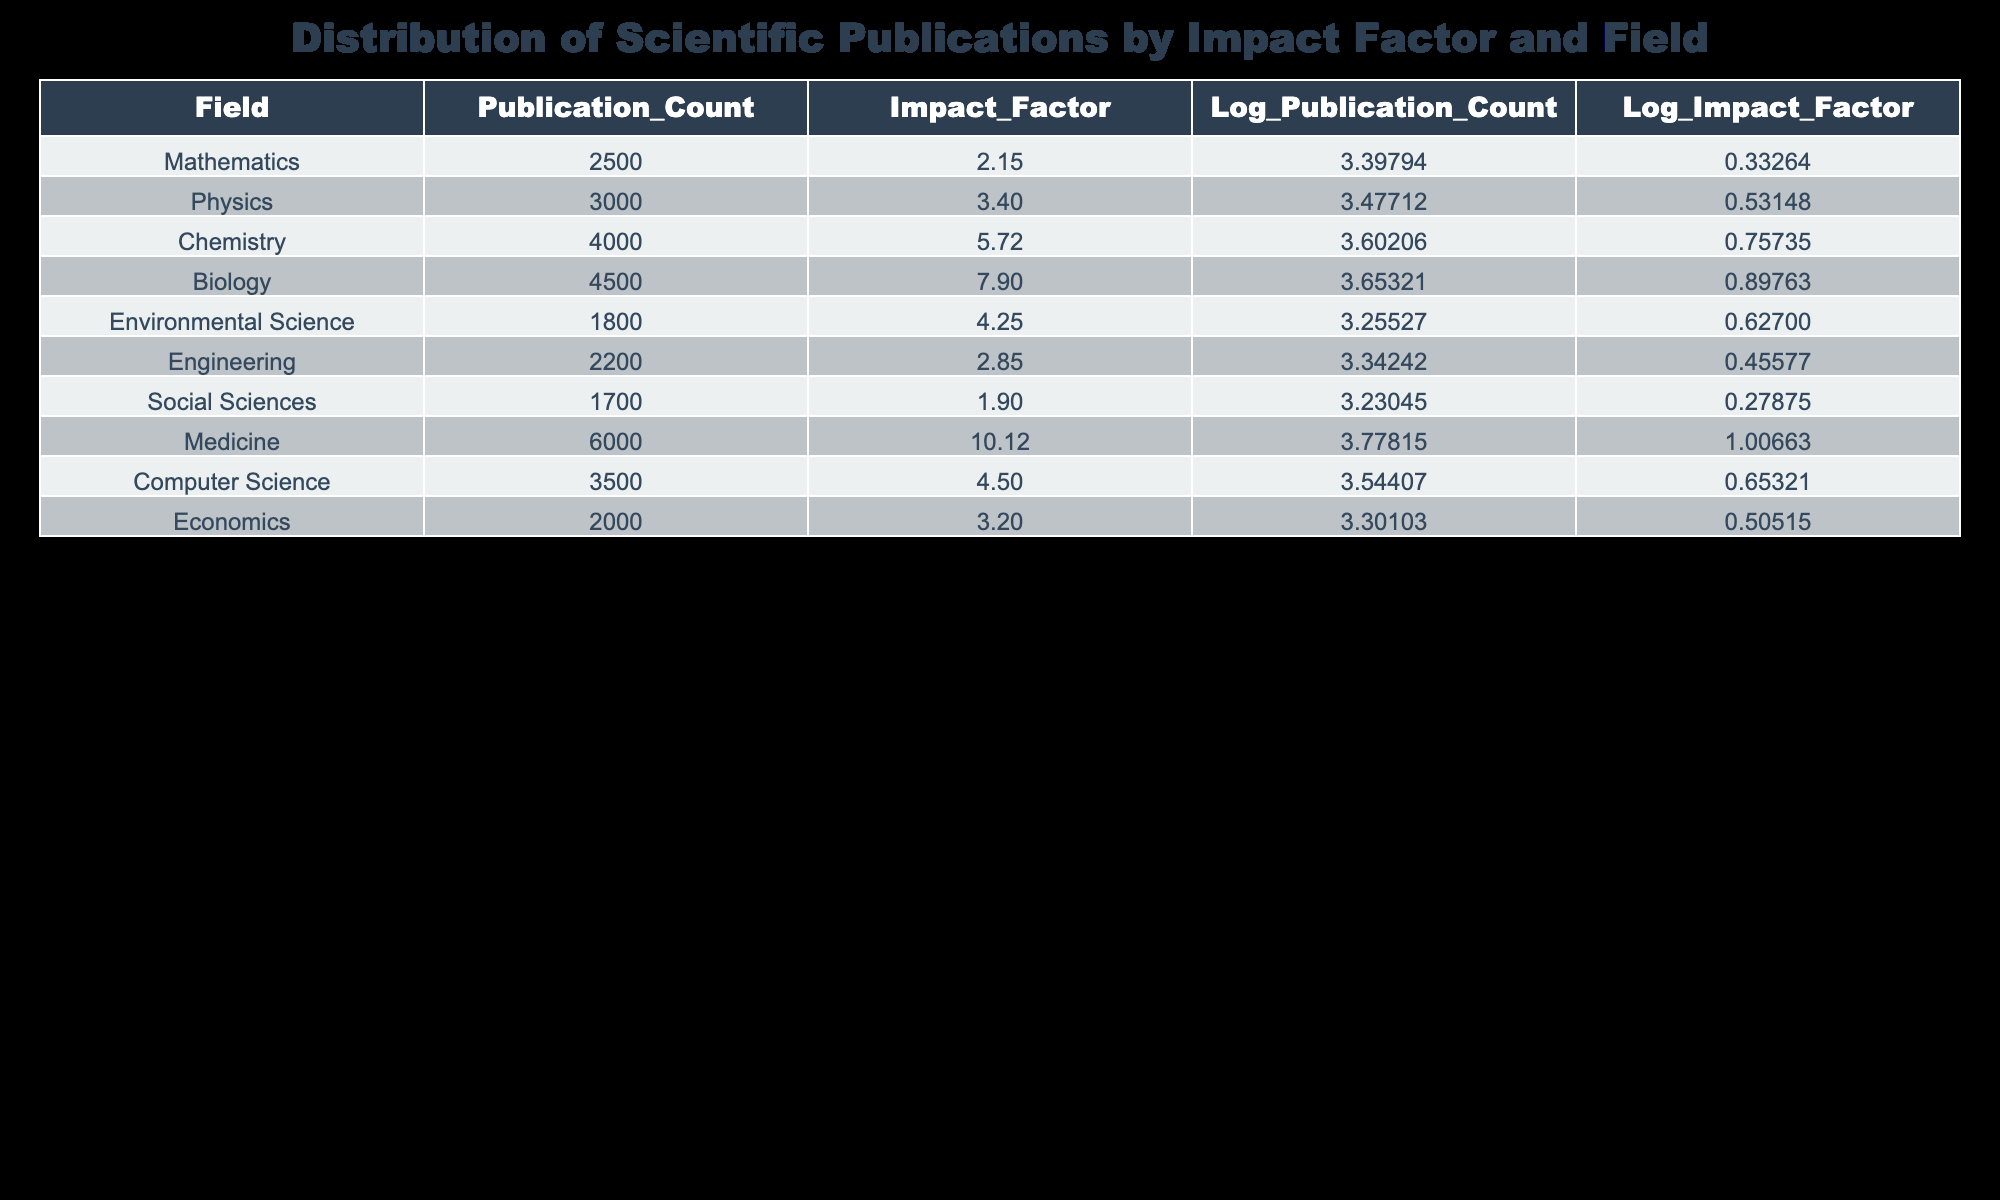What is the average impact factor of the fields listed? The impact factors of the fields are: 2.15, 3.40, 5.72, 7.90, 4.25, 2.85, 1.90, 10.12, 4.50, and 3.20. Adding these values gives a total of 41.89. Since there are 10 fields, the average impact factor is 41.89 divided by 10, which equals 4.189
Answer: 4.19 How many publications are there in the field of Medicine? Looking at the table, the field of Medicine has a publication count of 6000.
Answer: 6000 Which field has the highest number of publications? By examining the publication counts: Mathematics (2500), Physics (3000), Chemistry (4000), Biology (4500), Environmental Science (1800), Engineering (2200), Social Sciences (1700), Medicine (6000), Computer Science (3500), and Economics (2000), Medicine has the highest count at 6000.
Answer: Medicine Is the impact factor of Engineering greater than that of Mathematics? The impact factor of Engineering is 2.85 while for Mathematics it is 2.15. Since 2.85 is greater than 2.15, the statement is true.
Answer: Yes What is the total number of publications across all fields? The total publication count can be calculated by adding up all the published counts: 2500 + 3000 + 4000 + 4500 + 1800 + 2200 + 1700 + 6000 + 3500 + 2000 equals 20,200.
Answer: 20200 Which field has the lowest impact factor? The fields and their impact factors are: Mathematics (2.15), Physics (3.40), Chemistry (5.72), Biology (7.90), Environmental Science (4.25), Engineering (2.85), Social Sciences (1.90), Medicine (10.12), Computer Science (4.50), and Economics (3.20). The lowest impact factor belongs to Social Sciences at 1.90.
Answer: Social Sciences Calculate the difference in publication counts between Medicine and Environmental Science. The publication count for Medicine is 6000 and for Environmental Science it is 1800. To find the difference, subtract 1800 from 6000, resulting in 6000 - 1800 = 4200.
Answer: 4200 Is the publication count of Biology higher than that of Chemistry? The publication count for Biology is 4500 and for Chemistry, it is 4000. Comparing these, 4500 is indeed higher than 4000, making the statement true.
Answer: Yes What are the logarithmic values of the publication counts for Chemistry? From the table, the logarithmic value of the publication count for Chemistry is 3.60206.
Answer: 3.60206 